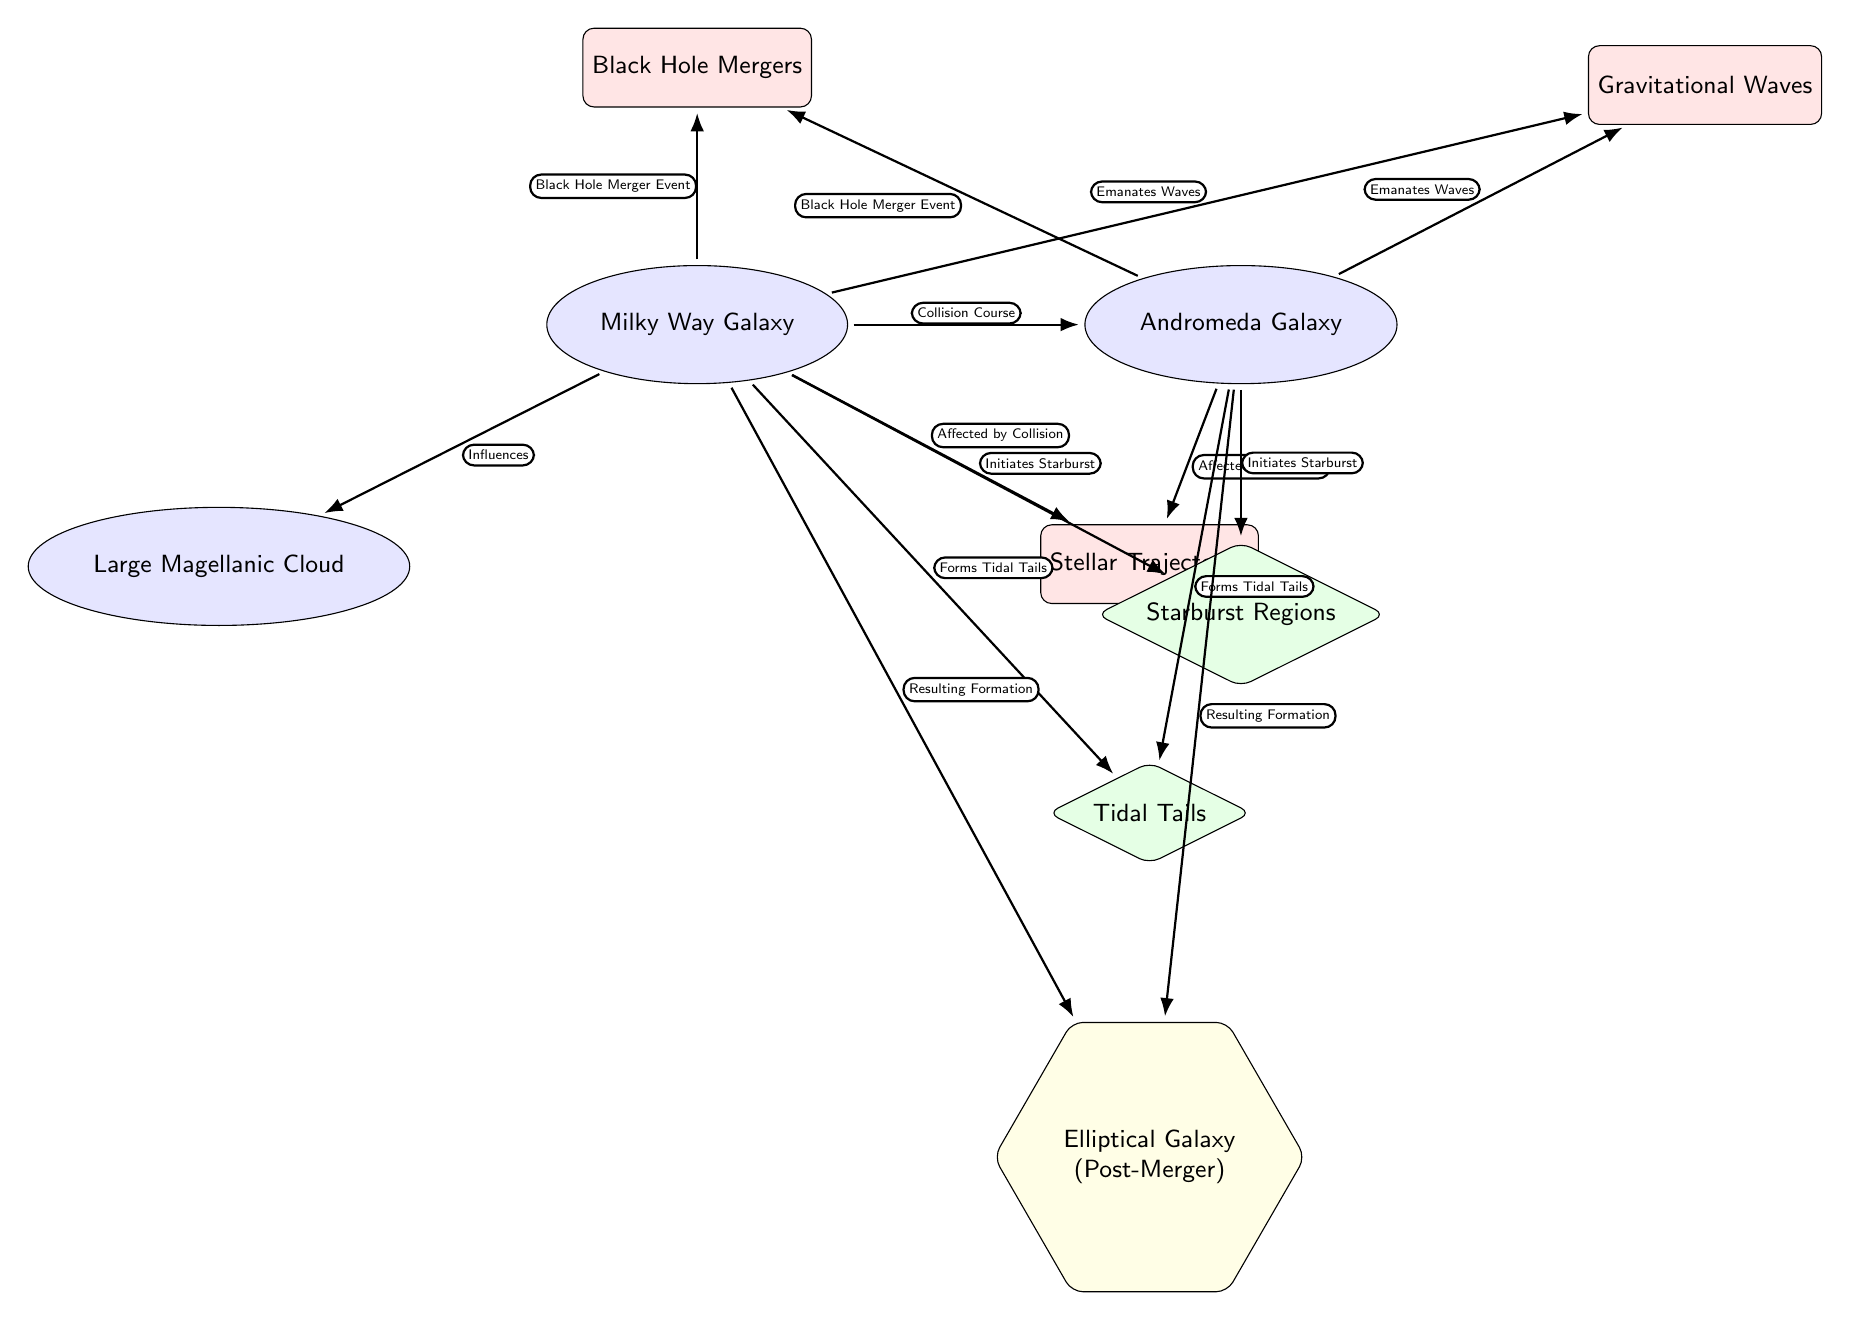What two galaxies are shown in the diagram? The diagram displays the Milky Way Galaxy and the Andromeda Galaxy as the main galaxies involved in the collision dynamics.
Answer: Milky Way Galaxy, Andromeda Galaxy How many events are indicated in the diagram? There are three events represented in the diagram: Stellar Trajectories, Gravitational Waves, and Black Hole Mergers. This can be counted by identifying the rectangles in the diagram.
Answer: 3 Which effect is associated with both galaxies? The Tidal Tails effect is associated with both the Milky Way Galaxy and the Andromeda Galaxy, as indicated by the edges connecting both galaxies to this node.
Answer: Tidal Tails What type of galaxy is indicated as the post-merger result? The resulting formation after the merger is depicted as an Elliptical Galaxy, which is suggested by the node labeled accordingly in the diagram.
Answer: Elliptical Galaxy What relationship describes the interaction between the Milky Way Galaxy and Andromeda Galaxy? The relationship described is "Collision Course", which is indicated by the edge connecting these two galaxy nodes directly.
Answer: Collision Course What initiates the formation of Starburst Regions according to the diagram? Both the Milky Way Galaxy and the Andromeda Galaxy initiate the formation of Starburst Regions as indicated by the edges leading from both galaxies to this effect.
Answer: Initiates Starburst Which event is said to emanate waves from both galaxies? Gravitational Waves are emitted as indicated by the edges from both the Milky Way Galaxy and the Andromeda Galaxy leading to this event node.
Answer: Gravitational Waves What influences the Milky Way Galaxy in the diagram? The Milky Way Galaxy is influenced by the Large Magellanic Cloud, which is represented by the edge leading to this galaxy.
Answer: Large Magellanic Cloud 